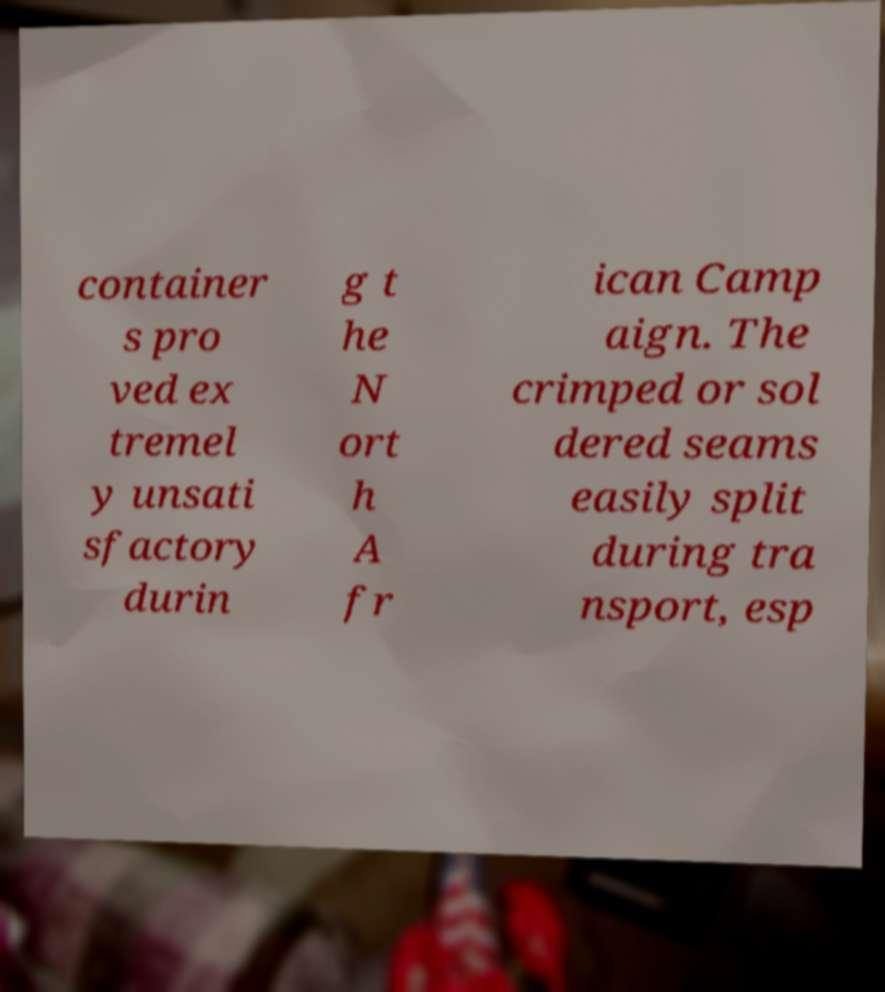Please read and relay the text visible in this image. What does it say? container s pro ved ex tremel y unsati sfactory durin g t he N ort h A fr ican Camp aign. The crimped or sol dered seams easily split during tra nsport, esp 